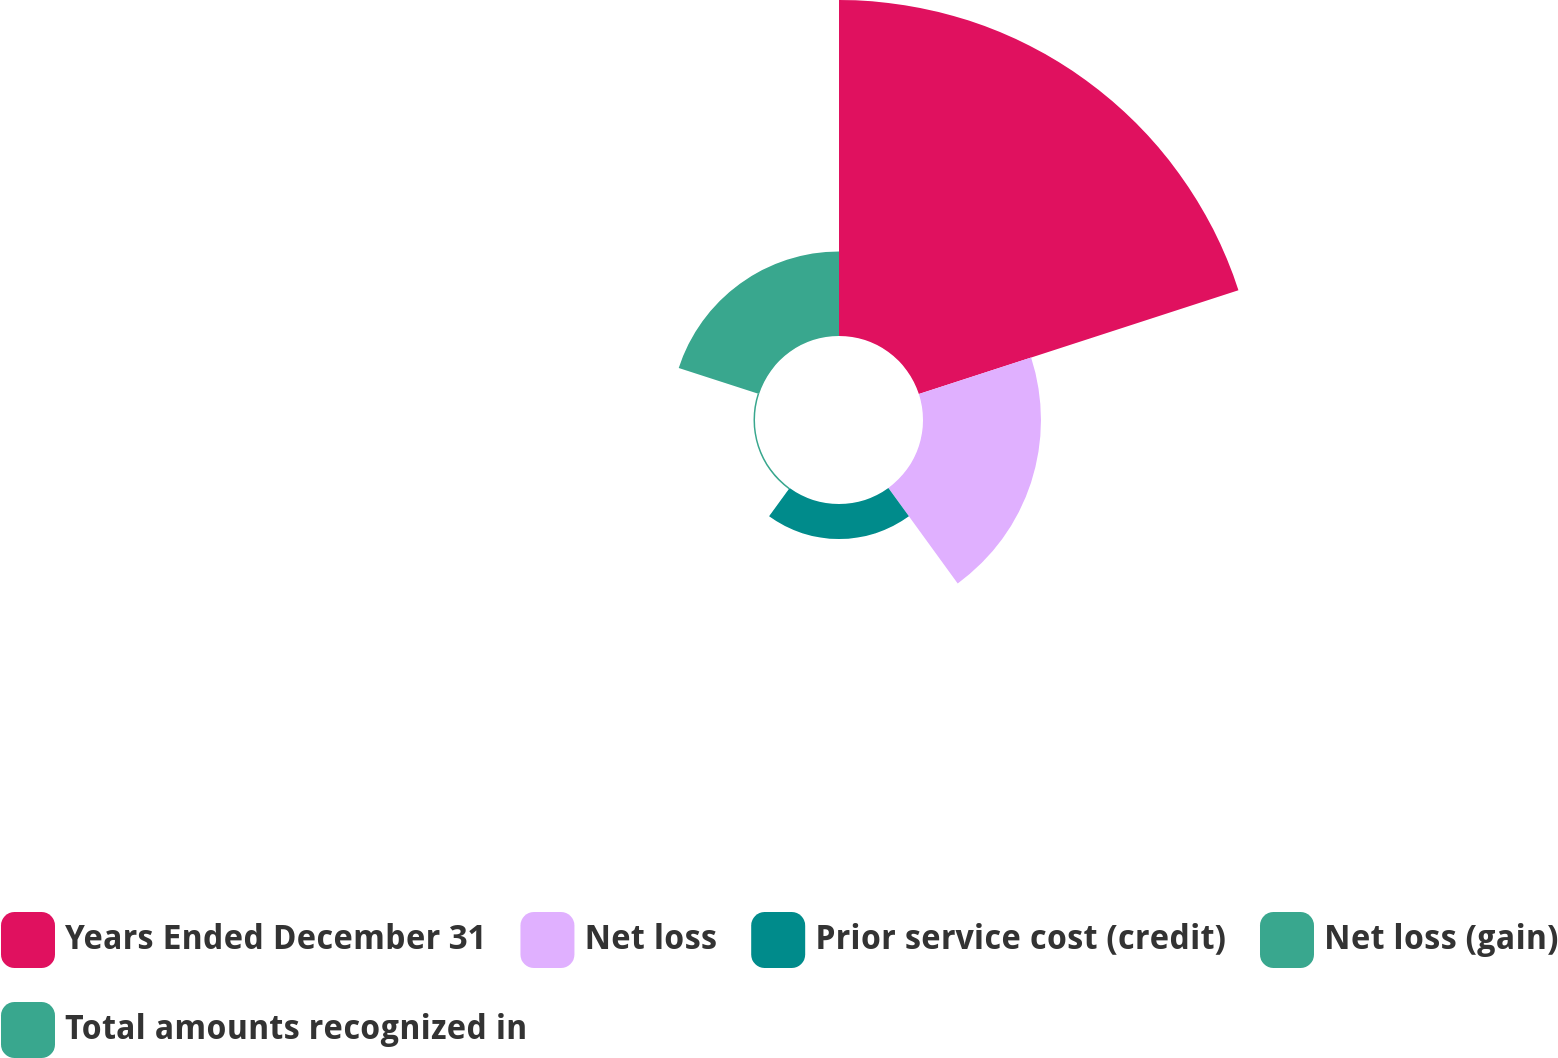<chart> <loc_0><loc_0><loc_500><loc_500><pie_chart><fcel>Years Ended December 31<fcel>Net loss<fcel>Prior service cost (credit)<fcel>Net loss (gain)<fcel>Total amounts recognized in<nl><fcel>58.44%<fcel>20.52%<fcel>6.08%<fcel>0.26%<fcel>14.7%<nl></chart> 